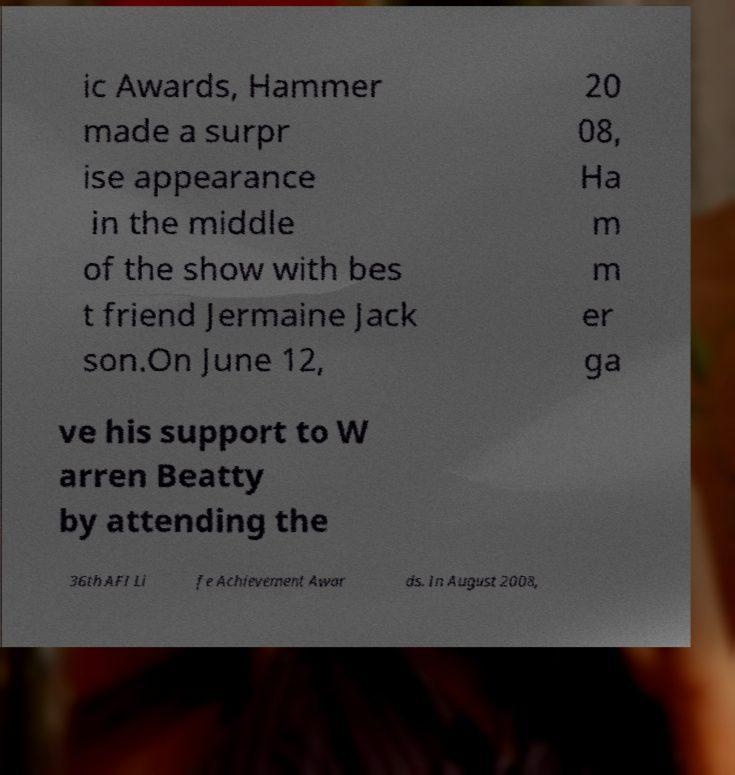Can you accurately transcribe the text from the provided image for me? ic Awards, Hammer made a surpr ise appearance in the middle of the show with bes t friend Jermaine Jack son.On June 12, 20 08, Ha m m er ga ve his support to W arren Beatty by attending the 36th AFI Li fe Achievement Awar ds. In August 2008, 